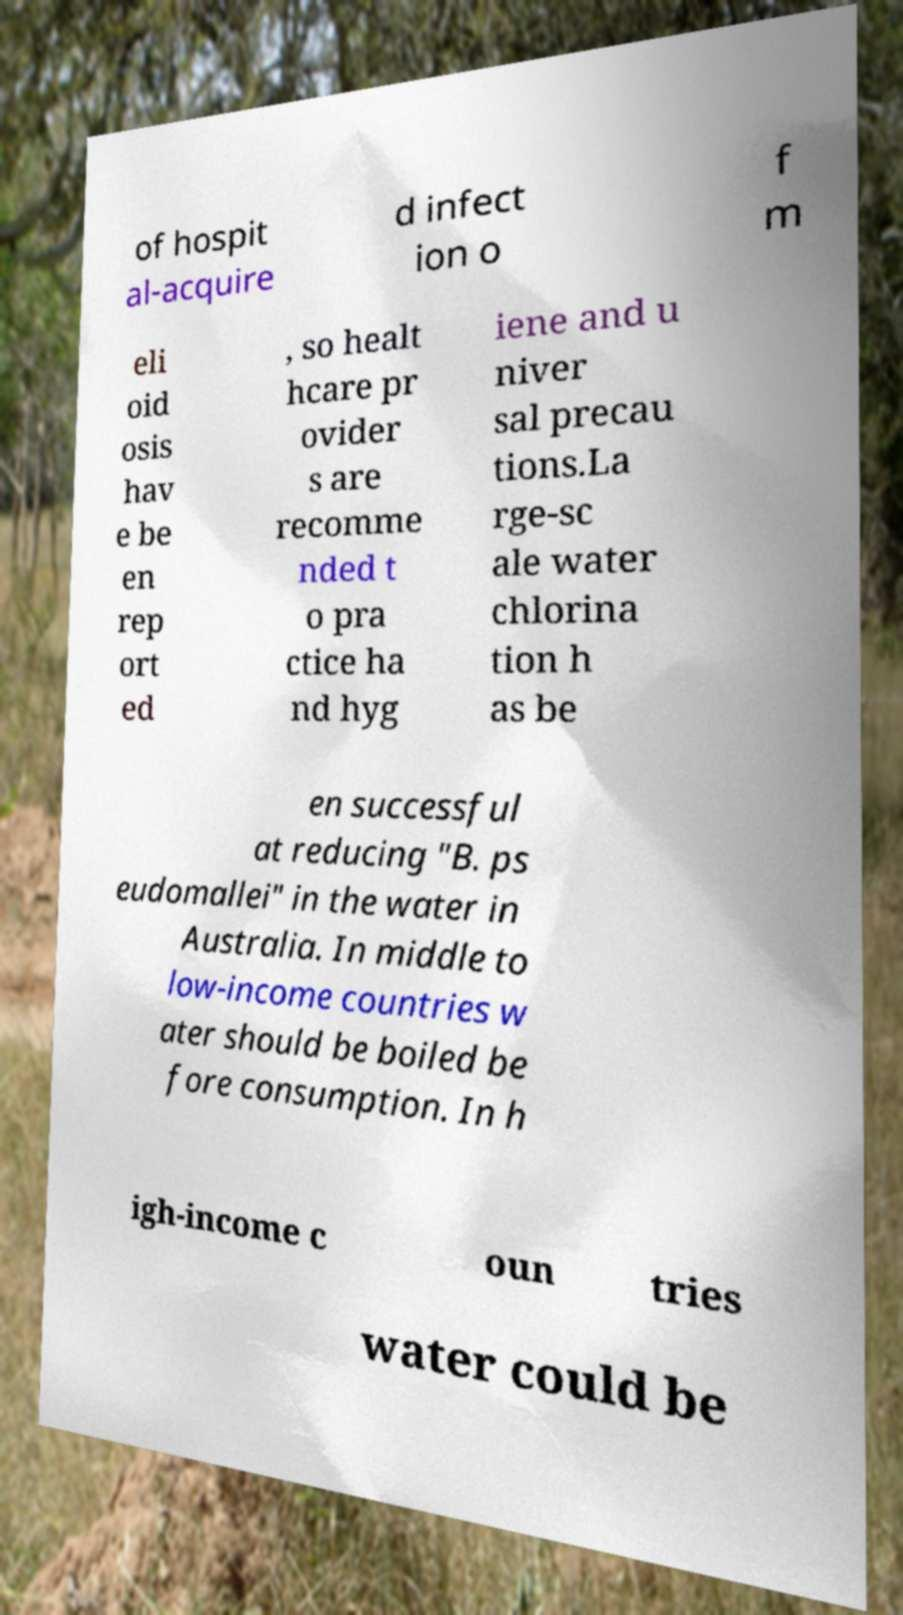Could you assist in decoding the text presented in this image and type it out clearly? of hospit al-acquire d infect ion o f m eli oid osis hav e be en rep ort ed , so healt hcare pr ovider s are recomme nded t o pra ctice ha nd hyg iene and u niver sal precau tions.La rge-sc ale water chlorina tion h as be en successful at reducing "B. ps eudomallei" in the water in Australia. In middle to low-income countries w ater should be boiled be fore consumption. In h igh-income c oun tries water could be 